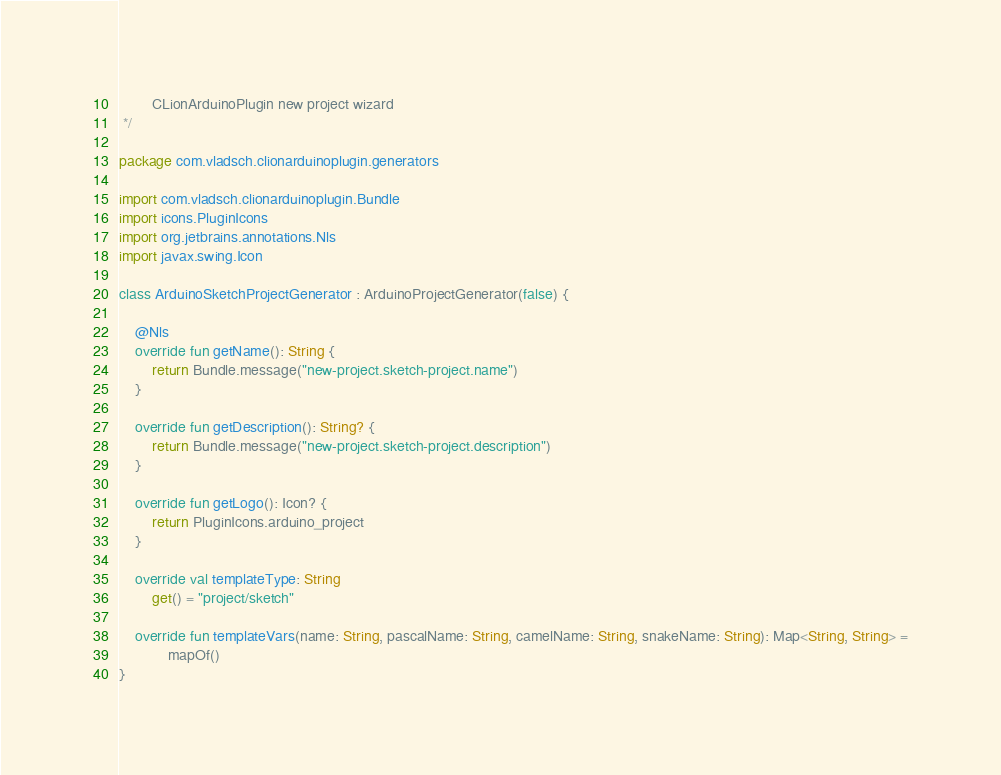Convert code to text. <code><loc_0><loc_0><loc_500><loc_500><_Kotlin_>        CLionArduinoPlugin new project wizard
 */

package com.vladsch.clionarduinoplugin.generators

import com.vladsch.clionarduinoplugin.Bundle
import icons.PluginIcons
import org.jetbrains.annotations.Nls
import javax.swing.Icon

class ArduinoSketchProjectGenerator : ArduinoProjectGenerator(false) {

    @Nls
    override fun getName(): String {
        return Bundle.message("new-project.sketch-project.name")
    }

    override fun getDescription(): String? {
        return Bundle.message("new-project.sketch-project.description")
    }

    override fun getLogo(): Icon? {
        return PluginIcons.arduino_project
    }

    override val templateType: String
        get() = "project/sketch"

    override fun templateVars(name: String, pascalName: String, camelName: String, snakeName: String): Map<String, String> =
            mapOf()
}
</code> 